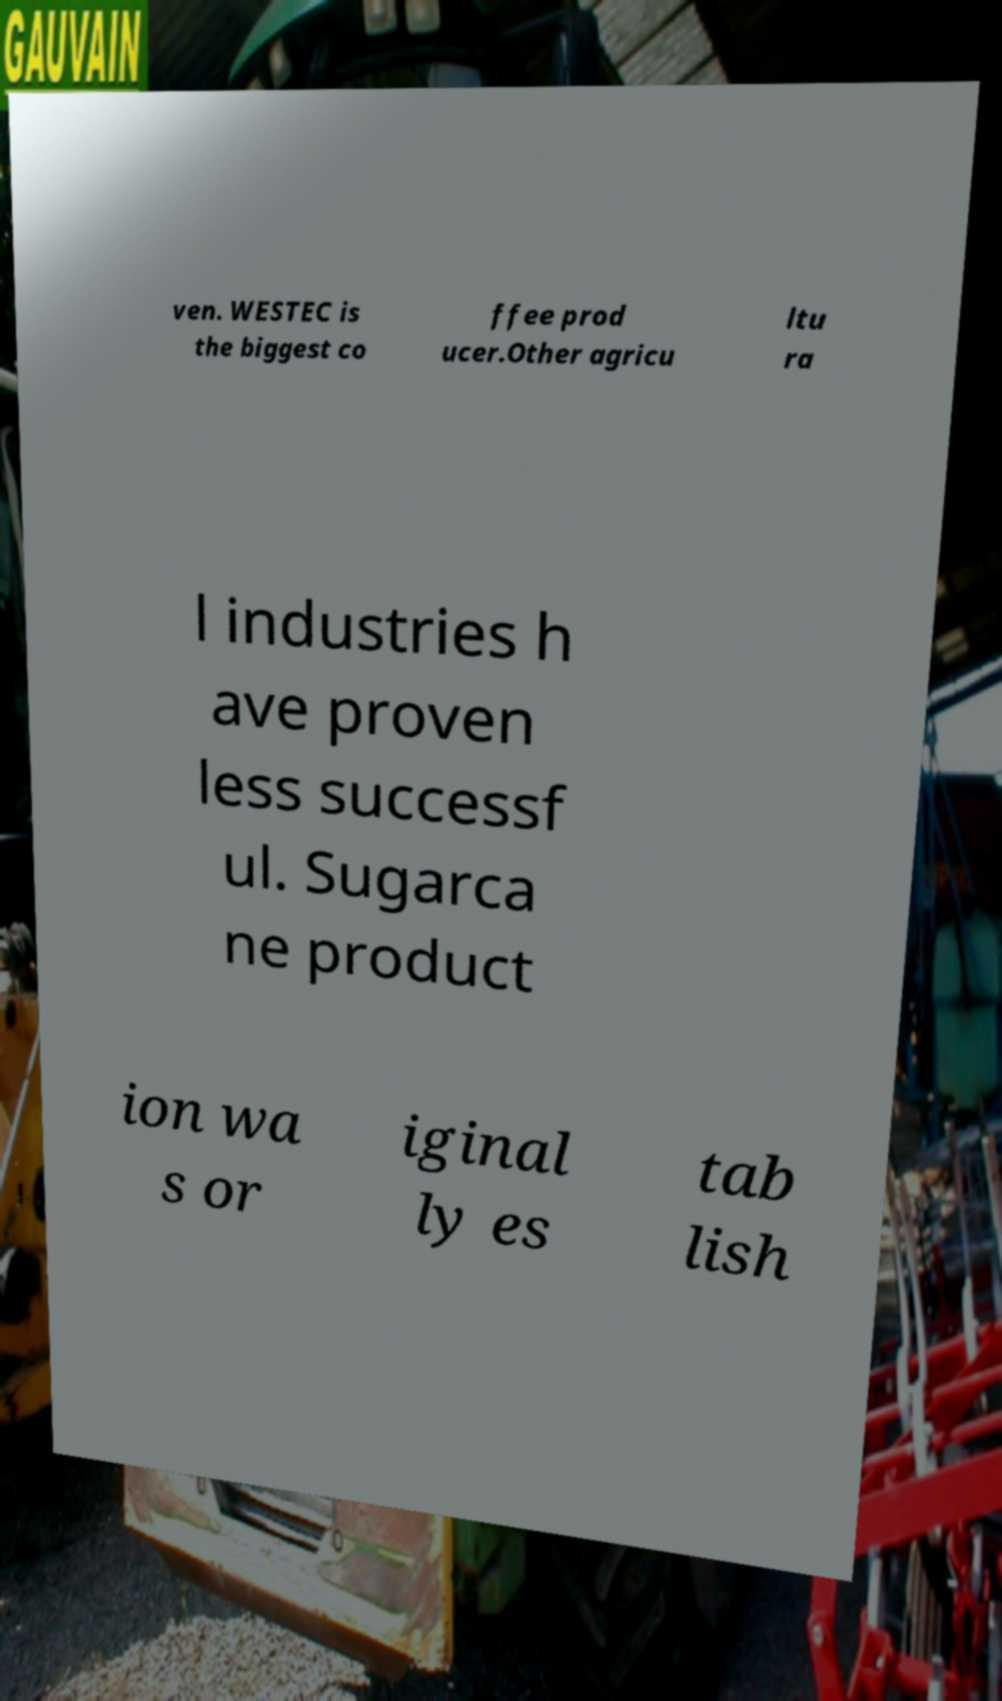Please read and relay the text visible in this image. What does it say? ven. WESTEC is the biggest co ffee prod ucer.Other agricu ltu ra l industries h ave proven less successf ul. Sugarca ne product ion wa s or iginal ly es tab lish 